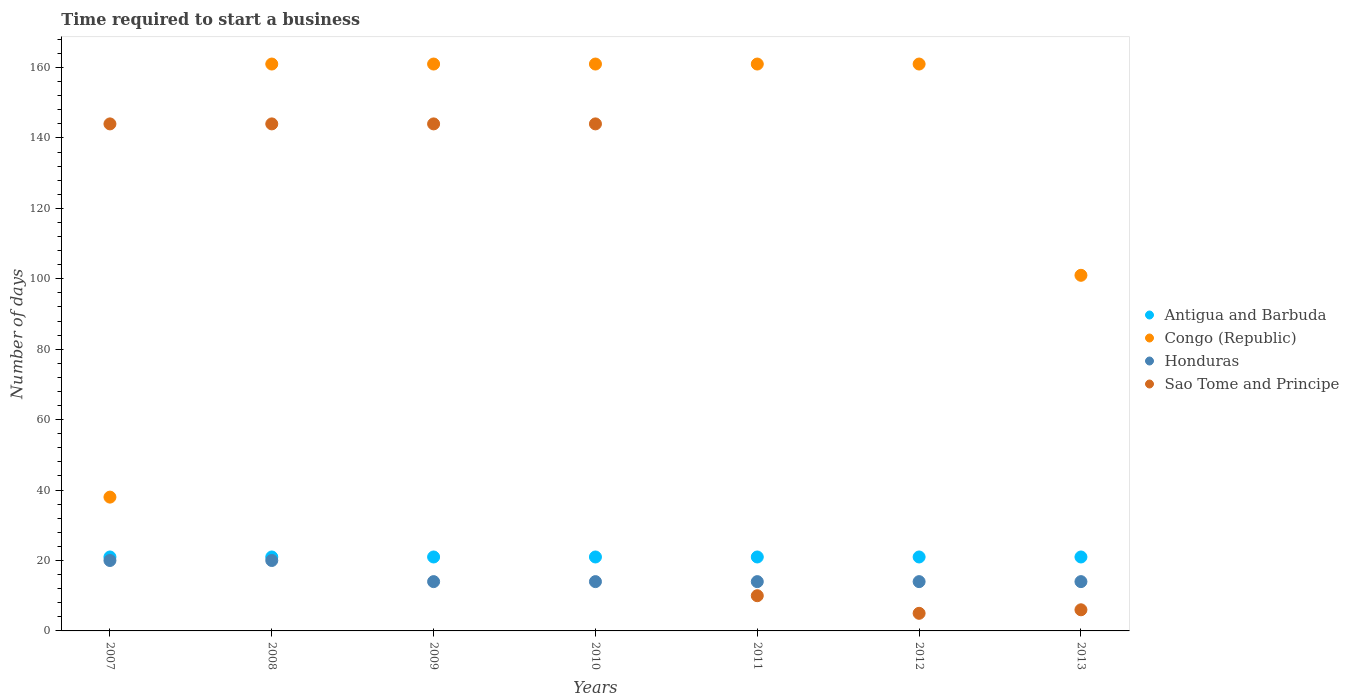How many different coloured dotlines are there?
Provide a short and direct response. 4. What is the number of days required to start a business in Sao Tome and Principe in 2007?
Your answer should be compact. 144. Across all years, what is the maximum number of days required to start a business in Sao Tome and Principe?
Ensure brevity in your answer.  144. Across all years, what is the minimum number of days required to start a business in Sao Tome and Principe?
Your response must be concise. 5. In which year was the number of days required to start a business in Antigua and Barbuda maximum?
Your response must be concise. 2007. In which year was the number of days required to start a business in Honduras minimum?
Offer a very short reply. 2009. What is the total number of days required to start a business in Honduras in the graph?
Provide a succinct answer. 110. What is the difference between the number of days required to start a business in Sao Tome and Principe in 2010 and that in 2013?
Ensure brevity in your answer.  138. What is the difference between the number of days required to start a business in Honduras in 2009 and the number of days required to start a business in Congo (Republic) in 2010?
Make the answer very short. -147. What is the average number of days required to start a business in Honduras per year?
Offer a very short reply. 15.71. In the year 2009, what is the difference between the number of days required to start a business in Antigua and Barbuda and number of days required to start a business in Congo (Republic)?
Your response must be concise. -140. What is the ratio of the number of days required to start a business in Sao Tome and Principe in 2012 to that in 2013?
Your answer should be very brief. 0.83. What is the difference between the highest and the second highest number of days required to start a business in Antigua and Barbuda?
Offer a very short reply. 0. What is the difference between the highest and the lowest number of days required to start a business in Congo (Republic)?
Provide a succinct answer. 123. In how many years, is the number of days required to start a business in Sao Tome and Principe greater than the average number of days required to start a business in Sao Tome and Principe taken over all years?
Make the answer very short. 4. Does the number of days required to start a business in Sao Tome and Principe monotonically increase over the years?
Keep it short and to the point. No. Is the number of days required to start a business in Honduras strictly greater than the number of days required to start a business in Sao Tome and Principe over the years?
Keep it short and to the point. No. Is the number of days required to start a business in Antigua and Barbuda strictly less than the number of days required to start a business in Sao Tome and Principe over the years?
Ensure brevity in your answer.  No. How many dotlines are there?
Provide a short and direct response. 4. How many years are there in the graph?
Your answer should be very brief. 7. Where does the legend appear in the graph?
Offer a very short reply. Center right. What is the title of the graph?
Offer a very short reply. Time required to start a business. What is the label or title of the X-axis?
Your answer should be very brief. Years. What is the label or title of the Y-axis?
Ensure brevity in your answer.  Number of days. What is the Number of days of Antigua and Barbuda in 2007?
Offer a very short reply. 21. What is the Number of days of Congo (Republic) in 2007?
Provide a succinct answer. 38. What is the Number of days of Sao Tome and Principe in 2007?
Your answer should be very brief. 144. What is the Number of days in Antigua and Barbuda in 2008?
Ensure brevity in your answer.  21. What is the Number of days of Congo (Republic) in 2008?
Keep it short and to the point. 161. What is the Number of days in Honduras in 2008?
Offer a very short reply. 20. What is the Number of days of Sao Tome and Principe in 2008?
Your answer should be very brief. 144. What is the Number of days in Congo (Republic) in 2009?
Give a very brief answer. 161. What is the Number of days of Honduras in 2009?
Ensure brevity in your answer.  14. What is the Number of days in Sao Tome and Principe in 2009?
Offer a very short reply. 144. What is the Number of days in Congo (Republic) in 2010?
Keep it short and to the point. 161. What is the Number of days of Sao Tome and Principe in 2010?
Offer a very short reply. 144. What is the Number of days of Antigua and Barbuda in 2011?
Offer a terse response. 21. What is the Number of days of Congo (Republic) in 2011?
Make the answer very short. 161. What is the Number of days of Honduras in 2011?
Your answer should be compact. 14. What is the Number of days of Antigua and Barbuda in 2012?
Ensure brevity in your answer.  21. What is the Number of days of Congo (Republic) in 2012?
Your response must be concise. 161. What is the Number of days in Honduras in 2012?
Your answer should be very brief. 14. What is the Number of days in Congo (Republic) in 2013?
Make the answer very short. 101. What is the Number of days of Honduras in 2013?
Provide a short and direct response. 14. Across all years, what is the maximum Number of days in Congo (Republic)?
Provide a succinct answer. 161. Across all years, what is the maximum Number of days in Sao Tome and Principe?
Provide a short and direct response. 144. Across all years, what is the minimum Number of days of Congo (Republic)?
Provide a succinct answer. 38. What is the total Number of days of Antigua and Barbuda in the graph?
Provide a succinct answer. 147. What is the total Number of days of Congo (Republic) in the graph?
Offer a terse response. 944. What is the total Number of days in Honduras in the graph?
Make the answer very short. 110. What is the total Number of days in Sao Tome and Principe in the graph?
Your response must be concise. 597. What is the difference between the Number of days of Congo (Republic) in 2007 and that in 2008?
Provide a short and direct response. -123. What is the difference between the Number of days in Honduras in 2007 and that in 2008?
Offer a very short reply. 0. What is the difference between the Number of days in Congo (Republic) in 2007 and that in 2009?
Provide a short and direct response. -123. What is the difference between the Number of days of Honduras in 2007 and that in 2009?
Your answer should be compact. 6. What is the difference between the Number of days in Sao Tome and Principe in 2007 and that in 2009?
Offer a very short reply. 0. What is the difference between the Number of days of Congo (Republic) in 2007 and that in 2010?
Ensure brevity in your answer.  -123. What is the difference between the Number of days of Sao Tome and Principe in 2007 and that in 2010?
Keep it short and to the point. 0. What is the difference between the Number of days in Antigua and Barbuda in 2007 and that in 2011?
Provide a succinct answer. 0. What is the difference between the Number of days of Congo (Republic) in 2007 and that in 2011?
Ensure brevity in your answer.  -123. What is the difference between the Number of days in Honduras in 2007 and that in 2011?
Provide a short and direct response. 6. What is the difference between the Number of days of Sao Tome and Principe in 2007 and that in 2011?
Offer a very short reply. 134. What is the difference between the Number of days in Antigua and Barbuda in 2007 and that in 2012?
Provide a succinct answer. 0. What is the difference between the Number of days of Congo (Republic) in 2007 and that in 2012?
Offer a very short reply. -123. What is the difference between the Number of days in Sao Tome and Principe in 2007 and that in 2012?
Your answer should be compact. 139. What is the difference between the Number of days in Antigua and Barbuda in 2007 and that in 2013?
Offer a terse response. 0. What is the difference between the Number of days of Congo (Republic) in 2007 and that in 2013?
Keep it short and to the point. -63. What is the difference between the Number of days of Honduras in 2007 and that in 2013?
Keep it short and to the point. 6. What is the difference between the Number of days of Sao Tome and Principe in 2007 and that in 2013?
Offer a very short reply. 138. What is the difference between the Number of days of Antigua and Barbuda in 2008 and that in 2009?
Make the answer very short. 0. What is the difference between the Number of days in Honduras in 2008 and that in 2009?
Make the answer very short. 6. What is the difference between the Number of days of Sao Tome and Principe in 2008 and that in 2009?
Offer a very short reply. 0. What is the difference between the Number of days of Antigua and Barbuda in 2008 and that in 2010?
Your answer should be compact. 0. What is the difference between the Number of days of Honduras in 2008 and that in 2010?
Offer a terse response. 6. What is the difference between the Number of days of Antigua and Barbuda in 2008 and that in 2011?
Your answer should be compact. 0. What is the difference between the Number of days in Congo (Republic) in 2008 and that in 2011?
Your response must be concise. 0. What is the difference between the Number of days of Sao Tome and Principe in 2008 and that in 2011?
Ensure brevity in your answer.  134. What is the difference between the Number of days in Antigua and Barbuda in 2008 and that in 2012?
Provide a succinct answer. 0. What is the difference between the Number of days of Congo (Republic) in 2008 and that in 2012?
Make the answer very short. 0. What is the difference between the Number of days of Honduras in 2008 and that in 2012?
Give a very brief answer. 6. What is the difference between the Number of days in Sao Tome and Principe in 2008 and that in 2012?
Offer a terse response. 139. What is the difference between the Number of days in Congo (Republic) in 2008 and that in 2013?
Keep it short and to the point. 60. What is the difference between the Number of days of Honduras in 2008 and that in 2013?
Your answer should be compact. 6. What is the difference between the Number of days in Sao Tome and Principe in 2008 and that in 2013?
Make the answer very short. 138. What is the difference between the Number of days in Sao Tome and Principe in 2009 and that in 2010?
Your response must be concise. 0. What is the difference between the Number of days in Congo (Republic) in 2009 and that in 2011?
Offer a very short reply. 0. What is the difference between the Number of days of Sao Tome and Principe in 2009 and that in 2011?
Make the answer very short. 134. What is the difference between the Number of days in Sao Tome and Principe in 2009 and that in 2012?
Provide a short and direct response. 139. What is the difference between the Number of days in Antigua and Barbuda in 2009 and that in 2013?
Offer a terse response. 0. What is the difference between the Number of days in Honduras in 2009 and that in 2013?
Your answer should be compact. 0. What is the difference between the Number of days of Sao Tome and Principe in 2009 and that in 2013?
Keep it short and to the point. 138. What is the difference between the Number of days of Congo (Republic) in 2010 and that in 2011?
Your answer should be very brief. 0. What is the difference between the Number of days of Sao Tome and Principe in 2010 and that in 2011?
Make the answer very short. 134. What is the difference between the Number of days of Congo (Republic) in 2010 and that in 2012?
Your answer should be very brief. 0. What is the difference between the Number of days in Honduras in 2010 and that in 2012?
Your answer should be compact. 0. What is the difference between the Number of days of Sao Tome and Principe in 2010 and that in 2012?
Your response must be concise. 139. What is the difference between the Number of days of Antigua and Barbuda in 2010 and that in 2013?
Your answer should be compact. 0. What is the difference between the Number of days in Honduras in 2010 and that in 2013?
Give a very brief answer. 0. What is the difference between the Number of days of Sao Tome and Principe in 2010 and that in 2013?
Your answer should be compact. 138. What is the difference between the Number of days of Congo (Republic) in 2011 and that in 2012?
Keep it short and to the point. 0. What is the difference between the Number of days of Antigua and Barbuda in 2011 and that in 2013?
Give a very brief answer. 0. What is the difference between the Number of days of Congo (Republic) in 2011 and that in 2013?
Make the answer very short. 60. What is the difference between the Number of days in Sao Tome and Principe in 2011 and that in 2013?
Make the answer very short. 4. What is the difference between the Number of days in Congo (Republic) in 2012 and that in 2013?
Your response must be concise. 60. What is the difference between the Number of days in Honduras in 2012 and that in 2013?
Make the answer very short. 0. What is the difference between the Number of days in Sao Tome and Principe in 2012 and that in 2013?
Ensure brevity in your answer.  -1. What is the difference between the Number of days of Antigua and Barbuda in 2007 and the Number of days of Congo (Republic) in 2008?
Provide a short and direct response. -140. What is the difference between the Number of days of Antigua and Barbuda in 2007 and the Number of days of Sao Tome and Principe in 2008?
Keep it short and to the point. -123. What is the difference between the Number of days of Congo (Republic) in 2007 and the Number of days of Sao Tome and Principe in 2008?
Offer a very short reply. -106. What is the difference between the Number of days in Honduras in 2007 and the Number of days in Sao Tome and Principe in 2008?
Ensure brevity in your answer.  -124. What is the difference between the Number of days in Antigua and Barbuda in 2007 and the Number of days in Congo (Republic) in 2009?
Provide a short and direct response. -140. What is the difference between the Number of days of Antigua and Barbuda in 2007 and the Number of days of Sao Tome and Principe in 2009?
Provide a succinct answer. -123. What is the difference between the Number of days in Congo (Republic) in 2007 and the Number of days in Honduras in 2009?
Keep it short and to the point. 24. What is the difference between the Number of days of Congo (Republic) in 2007 and the Number of days of Sao Tome and Principe in 2009?
Make the answer very short. -106. What is the difference between the Number of days in Honduras in 2007 and the Number of days in Sao Tome and Principe in 2009?
Your response must be concise. -124. What is the difference between the Number of days in Antigua and Barbuda in 2007 and the Number of days in Congo (Republic) in 2010?
Offer a terse response. -140. What is the difference between the Number of days of Antigua and Barbuda in 2007 and the Number of days of Sao Tome and Principe in 2010?
Ensure brevity in your answer.  -123. What is the difference between the Number of days of Congo (Republic) in 2007 and the Number of days of Honduras in 2010?
Your answer should be very brief. 24. What is the difference between the Number of days of Congo (Republic) in 2007 and the Number of days of Sao Tome and Principe in 2010?
Offer a very short reply. -106. What is the difference between the Number of days in Honduras in 2007 and the Number of days in Sao Tome and Principe in 2010?
Provide a succinct answer. -124. What is the difference between the Number of days of Antigua and Barbuda in 2007 and the Number of days of Congo (Republic) in 2011?
Offer a very short reply. -140. What is the difference between the Number of days of Antigua and Barbuda in 2007 and the Number of days of Honduras in 2011?
Keep it short and to the point. 7. What is the difference between the Number of days of Honduras in 2007 and the Number of days of Sao Tome and Principe in 2011?
Make the answer very short. 10. What is the difference between the Number of days in Antigua and Barbuda in 2007 and the Number of days in Congo (Republic) in 2012?
Your answer should be very brief. -140. What is the difference between the Number of days of Antigua and Barbuda in 2007 and the Number of days of Honduras in 2012?
Your answer should be very brief. 7. What is the difference between the Number of days of Antigua and Barbuda in 2007 and the Number of days of Sao Tome and Principe in 2012?
Ensure brevity in your answer.  16. What is the difference between the Number of days in Congo (Republic) in 2007 and the Number of days in Honduras in 2012?
Provide a succinct answer. 24. What is the difference between the Number of days of Honduras in 2007 and the Number of days of Sao Tome and Principe in 2012?
Offer a terse response. 15. What is the difference between the Number of days of Antigua and Barbuda in 2007 and the Number of days of Congo (Republic) in 2013?
Provide a short and direct response. -80. What is the difference between the Number of days in Antigua and Barbuda in 2007 and the Number of days in Honduras in 2013?
Keep it short and to the point. 7. What is the difference between the Number of days of Antigua and Barbuda in 2008 and the Number of days of Congo (Republic) in 2009?
Your answer should be very brief. -140. What is the difference between the Number of days in Antigua and Barbuda in 2008 and the Number of days in Honduras in 2009?
Provide a short and direct response. 7. What is the difference between the Number of days of Antigua and Barbuda in 2008 and the Number of days of Sao Tome and Principe in 2009?
Offer a very short reply. -123. What is the difference between the Number of days of Congo (Republic) in 2008 and the Number of days of Honduras in 2009?
Your answer should be very brief. 147. What is the difference between the Number of days in Congo (Republic) in 2008 and the Number of days in Sao Tome and Principe in 2009?
Offer a very short reply. 17. What is the difference between the Number of days of Honduras in 2008 and the Number of days of Sao Tome and Principe in 2009?
Give a very brief answer. -124. What is the difference between the Number of days of Antigua and Barbuda in 2008 and the Number of days of Congo (Republic) in 2010?
Your answer should be compact. -140. What is the difference between the Number of days in Antigua and Barbuda in 2008 and the Number of days in Honduras in 2010?
Make the answer very short. 7. What is the difference between the Number of days in Antigua and Barbuda in 2008 and the Number of days in Sao Tome and Principe in 2010?
Ensure brevity in your answer.  -123. What is the difference between the Number of days of Congo (Republic) in 2008 and the Number of days of Honduras in 2010?
Offer a terse response. 147. What is the difference between the Number of days in Congo (Republic) in 2008 and the Number of days in Sao Tome and Principe in 2010?
Offer a very short reply. 17. What is the difference between the Number of days of Honduras in 2008 and the Number of days of Sao Tome and Principe in 2010?
Offer a very short reply. -124. What is the difference between the Number of days of Antigua and Barbuda in 2008 and the Number of days of Congo (Republic) in 2011?
Your answer should be compact. -140. What is the difference between the Number of days of Antigua and Barbuda in 2008 and the Number of days of Sao Tome and Principe in 2011?
Make the answer very short. 11. What is the difference between the Number of days of Congo (Republic) in 2008 and the Number of days of Honduras in 2011?
Make the answer very short. 147. What is the difference between the Number of days in Congo (Republic) in 2008 and the Number of days in Sao Tome and Principe in 2011?
Your answer should be compact. 151. What is the difference between the Number of days in Honduras in 2008 and the Number of days in Sao Tome and Principe in 2011?
Provide a succinct answer. 10. What is the difference between the Number of days of Antigua and Barbuda in 2008 and the Number of days of Congo (Republic) in 2012?
Your response must be concise. -140. What is the difference between the Number of days in Antigua and Barbuda in 2008 and the Number of days in Honduras in 2012?
Keep it short and to the point. 7. What is the difference between the Number of days of Congo (Republic) in 2008 and the Number of days of Honduras in 2012?
Offer a terse response. 147. What is the difference between the Number of days of Congo (Republic) in 2008 and the Number of days of Sao Tome and Principe in 2012?
Give a very brief answer. 156. What is the difference between the Number of days in Honduras in 2008 and the Number of days in Sao Tome and Principe in 2012?
Provide a short and direct response. 15. What is the difference between the Number of days of Antigua and Barbuda in 2008 and the Number of days of Congo (Republic) in 2013?
Offer a terse response. -80. What is the difference between the Number of days in Antigua and Barbuda in 2008 and the Number of days in Honduras in 2013?
Your response must be concise. 7. What is the difference between the Number of days of Congo (Republic) in 2008 and the Number of days of Honduras in 2013?
Your answer should be compact. 147. What is the difference between the Number of days in Congo (Republic) in 2008 and the Number of days in Sao Tome and Principe in 2013?
Offer a very short reply. 155. What is the difference between the Number of days in Antigua and Barbuda in 2009 and the Number of days in Congo (Republic) in 2010?
Your answer should be very brief. -140. What is the difference between the Number of days in Antigua and Barbuda in 2009 and the Number of days in Honduras in 2010?
Make the answer very short. 7. What is the difference between the Number of days in Antigua and Barbuda in 2009 and the Number of days in Sao Tome and Principe in 2010?
Offer a very short reply. -123. What is the difference between the Number of days of Congo (Republic) in 2009 and the Number of days of Honduras in 2010?
Offer a very short reply. 147. What is the difference between the Number of days of Honduras in 2009 and the Number of days of Sao Tome and Principe in 2010?
Your answer should be very brief. -130. What is the difference between the Number of days in Antigua and Barbuda in 2009 and the Number of days in Congo (Republic) in 2011?
Provide a succinct answer. -140. What is the difference between the Number of days of Antigua and Barbuda in 2009 and the Number of days of Honduras in 2011?
Your response must be concise. 7. What is the difference between the Number of days in Congo (Republic) in 2009 and the Number of days in Honduras in 2011?
Your response must be concise. 147. What is the difference between the Number of days in Congo (Republic) in 2009 and the Number of days in Sao Tome and Principe in 2011?
Your answer should be compact. 151. What is the difference between the Number of days in Antigua and Barbuda in 2009 and the Number of days in Congo (Republic) in 2012?
Your answer should be very brief. -140. What is the difference between the Number of days of Antigua and Barbuda in 2009 and the Number of days of Honduras in 2012?
Your answer should be compact. 7. What is the difference between the Number of days of Antigua and Barbuda in 2009 and the Number of days of Sao Tome and Principe in 2012?
Your answer should be compact. 16. What is the difference between the Number of days of Congo (Republic) in 2009 and the Number of days of Honduras in 2012?
Provide a succinct answer. 147. What is the difference between the Number of days in Congo (Republic) in 2009 and the Number of days in Sao Tome and Principe in 2012?
Keep it short and to the point. 156. What is the difference between the Number of days of Honduras in 2009 and the Number of days of Sao Tome and Principe in 2012?
Make the answer very short. 9. What is the difference between the Number of days of Antigua and Barbuda in 2009 and the Number of days of Congo (Republic) in 2013?
Your response must be concise. -80. What is the difference between the Number of days in Antigua and Barbuda in 2009 and the Number of days in Honduras in 2013?
Ensure brevity in your answer.  7. What is the difference between the Number of days of Antigua and Barbuda in 2009 and the Number of days of Sao Tome and Principe in 2013?
Give a very brief answer. 15. What is the difference between the Number of days of Congo (Republic) in 2009 and the Number of days of Honduras in 2013?
Your answer should be compact. 147. What is the difference between the Number of days of Congo (Republic) in 2009 and the Number of days of Sao Tome and Principe in 2013?
Keep it short and to the point. 155. What is the difference between the Number of days of Antigua and Barbuda in 2010 and the Number of days of Congo (Republic) in 2011?
Your answer should be very brief. -140. What is the difference between the Number of days in Antigua and Barbuda in 2010 and the Number of days in Sao Tome and Principe in 2011?
Provide a short and direct response. 11. What is the difference between the Number of days of Congo (Republic) in 2010 and the Number of days of Honduras in 2011?
Provide a succinct answer. 147. What is the difference between the Number of days of Congo (Republic) in 2010 and the Number of days of Sao Tome and Principe in 2011?
Provide a succinct answer. 151. What is the difference between the Number of days of Antigua and Barbuda in 2010 and the Number of days of Congo (Republic) in 2012?
Provide a succinct answer. -140. What is the difference between the Number of days in Antigua and Barbuda in 2010 and the Number of days in Honduras in 2012?
Your response must be concise. 7. What is the difference between the Number of days in Antigua and Barbuda in 2010 and the Number of days in Sao Tome and Principe in 2012?
Make the answer very short. 16. What is the difference between the Number of days in Congo (Republic) in 2010 and the Number of days in Honduras in 2012?
Keep it short and to the point. 147. What is the difference between the Number of days in Congo (Republic) in 2010 and the Number of days in Sao Tome and Principe in 2012?
Your answer should be very brief. 156. What is the difference between the Number of days in Antigua and Barbuda in 2010 and the Number of days in Congo (Republic) in 2013?
Ensure brevity in your answer.  -80. What is the difference between the Number of days in Antigua and Barbuda in 2010 and the Number of days in Honduras in 2013?
Your answer should be compact. 7. What is the difference between the Number of days in Antigua and Barbuda in 2010 and the Number of days in Sao Tome and Principe in 2013?
Give a very brief answer. 15. What is the difference between the Number of days of Congo (Republic) in 2010 and the Number of days of Honduras in 2013?
Keep it short and to the point. 147. What is the difference between the Number of days of Congo (Republic) in 2010 and the Number of days of Sao Tome and Principe in 2013?
Offer a very short reply. 155. What is the difference between the Number of days of Antigua and Barbuda in 2011 and the Number of days of Congo (Republic) in 2012?
Provide a short and direct response. -140. What is the difference between the Number of days in Antigua and Barbuda in 2011 and the Number of days in Honduras in 2012?
Give a very brief answer. 7. What is the difference between the Number of days of Antigua and Barbuda in 2011 and the Number of days of Sao Tome and Principe in 2012?
Give a very brief answer. 16. What is the difference between the Number of days in Congo (Republic) in 2011 and the Number of days in Honduras in 2012?
Provide a succinct answer. 147. What is the difference between the Number of days in Congo (Republic) in 2011 and the Number of days in Sao Tome and Principe in 2012?
Offer a terse response. 156. What is the difference between the Number of days of Honduras in 2011 and the Number of days of Sao Tome and Principe in 2012?
Your answer should be very brief. 9. What is the difference between the Number of days in Antigua and Barbuda in 2011 and the Number of days in Congo (Republic) in 2013?
Your answer should be compact. -80. What is the difference between the Number of days of Antigua and Barbuda in 2011 and the Number of days of Honduras in 2013?
Offer a terse response. 7. What is the difference between the Number of days of Antigua and Barbuda in 2011 and the Number of days of Sao Tome and Principe in 2013?
Make the answer very short. 15. What is the difference between the Number of days in Congo (Republic) in 2011 and the Number of days in Honduras in 2013?
Make the answer very short. 147. What is the difference between the Number of days in Congo (Republic) in 2011 and the Number of days in Sao Tome and Principe in 2013?
Your response must be concise. 155. What is the difference between the Number of days in Honduras in 2011 and the Number of days in Sao Tome and Principe in 2013?
Your response must be concise. 8. What is the difference between the Number of days in Antigua and Barbuda in 2012 and the Number of days in Congo (Republic) in 2013?
Keep it short and to the point. -80. What is the difference between the Number of days of Congo (Republic) in 2012 and the Number of days of Honduras in 2013?
Provide a succinct answer. 147. What is the difference between the Number of days of Congo (Republic) in 2012 and the Number of days of Sao Tome and Principe in 2013?
Your answer should be very brief. 155. What is the average Number of days in Congo (Republic) per year?
Ensure brevity in your answer.  134.86. What is the average Number of days of Honduras per year?
Keep it short and to the point. 15.71. What is the average Number of days of Sao Tome and Principe per year?
Your answer should be very brief. 85.29. In the year 2007, what is the difference between the Number of days of Antigua and Barbuda and Number of days of Congo (Republic)?
Provide a short and direct response. -17. In the year 2007, what is the difference between the Number of days in Antigua and Barbuda and Number of days in Honduras?
Offer a terse response. 1. In the year 2007, what is the difference between the Number of days of Antigua and Barbuda and Number of days of Sao Tome and Principe?
Offer a terse response. -123. In the year 2007, what is the difference between the Number of days in Congo (Republic) and Number of days in Honduras?
Provide a succinct answer. 18. In the year 2007, what is the difference between the Number of days in Congo (Republic) and Number of days in Sao Tome and Principe?
Your answer should be very brief. -106. In the year 2007, what is the difference between the Number of days of Honduras and Number of days of Sao Tome and Principe?
Ensure brevity in your answer.  -124. In the year 2008, what is the difference between the Number of days of Antigua and Barbuda and Number of days of Congo (Republic)?
Make the answer very short. -140. In the year 2008, what is the difference between the Number of days in Antigua and Barbuda and Number of days in Honduras?
Provide a short and direct response. 1. In the year 2008, what is the difference between the Number of days of Antigua and Barbuda and Number of days of Sao Tome and Principe?
Your response must be concise. -123. In the year 2008, what is the difference between the Number of days of Congo (Republic) and Number of days of Honduras?
Your response must be concise. 141. In the year 2008, what is the difference between the Number of days of Honduras and Number of days of Sao Tome and Principe?
Offer a terse response. -124. In the year 2009, what is the difference between the Number of days of Antigua and Barbuda and Number of days of Congo (Republic)?
Make the answer very short. -140. In the year 2009, what is the difference between the Number of days of Antigua and Barbuda and Number of days of Sao Tome and Principe?
Ensure brevity in your answer.  -123. In the year 2009, what is the difference between the Number of days in Congo (Republic) and Number of days in Honduras?
Provide a short and direct response. 147. In the year 2009, what is the difference between the Number of days of Honduras and Number of days of Sao Tome and Principe?
Your response must be concise. -130. In the year 2010, what is the difference between the Number of days of Antigua and Barbuda and Number of days of Congo (Republic)?
Provide a short and direct response. -140. In the year 2010, what is the difference between the Number of days in Antigua and Barbuda and Number of days in Honduras?
Make the answer very short. 7. In the year 2010, what is the difference between the Number of days in Antigua and Barbuda and Number of days in Sao Tome and Principe?
Provide a succinct answer. -123. In the year 2010, what is the difference between the Number of days in Congo (Republic) and Number of days in Honduras?
Offer a very short reply. 147. In the year 2010, what is the difference between the Number of days in Congo (Republic) and Number of days in Sao Tome and Principe?
Give a very brief answer. 17. In the year 2010, what is the difference between the Number of days in Honduras and Number of days in Sao Tome and Principe?
Provide a succinct answer. -130. In the year 2011, what is the difference between the Number of days of Antigua and Barbuda and Number of days of Congo (Republic)?
Ensure brevity in your answer.  -140. In the year 2011, what is the difference between the Number of days of Antigua and Barbuda and Number of days of Sao Tome and Principe?
Make the answer very short. 11. In the year 2011, what is the difference between the Number of days of Congo (Republic) and Number of days of Honduras?
Your answer should be compact. 147. In the year 2011, what is the difference between the Number of days in Congo (Republic) and Number of days in Sao Tome and Principe?
Provide a short and direct response. 151. In the year 2012, what is the difference between the Number of days in Antigua and Barbuda and Number of days in Congo (Republic)?
Make the answer very short. -140. In the year 2012, what is the difference between the Number of days of Congo (Republic) and Number of days of Honduras?
Provide a short and direct response. 147. In the year 2012, what is the difference between the Number of days in Congo (Republic) and Number of days in Sao Tome and Principe?
Your answer should be very brief. 156. In the year 2013, what is the difference between the Number of days of Antigua and Barbuda and Number of days of Congo (Republic)?
Your answer should be compact. -80. In the year 2013, what is the difference between the Number of days in Antigua and Barbuda and Number of days in Sao Tome and Principe?
Give a very brief answer. 15. In the year 2013, what is the difference between the Number of days in Congo (Republic) and Number of days in Honduras?
Your response must be concise. 87. What is the ratio of the Number of days in Antigua and Barbuda in 2007 to that in 2008?
Your answer should be compact. 1. What is the ratio of the Number of days in Congo (Republic) in 2007 to that in 2008?
Offer a very short reply. 0.24. What is the ratio of the Number of days in Sao Tome and Principe in 2007 to that in 2008?
Provide a short and direct response. 1. What is the ratio of the Number of days in Congo (Republic) in 2007 to that in 2009?
Your response must be concise. 0.24. What is the ratio of the Number of days in Honduras in 2007 to that in 2009?
Make the answer very short. 1.43. What is the ratio of the Number of days in Sao Tome and Principe in 2007 to that in 2009?
Ensure brevity in your answer.  1. What is the ratio of the Number of days of Congo (Republic) in 2007 to that in 2010?
Make the answer very short. 0.24. What is the ratio of the Number of days in Honduras in 2007 to that in 2010?
Offer a very short reply. 1.43. What is the ratio of the Number of days of Sao Tome and Principe in 2007 to that in 2010?
Offer a very short reply. 1. What is the ratio of the Number of days of Antigua and Barbuda in 2007 to that in 2011?
Offer a very short reply. 1. What is the ratio of the Number of days of Congo (Republic) in 2007 to that in 2011?
Ensure brevity in your answer.  0.24. What is the ratio of the Number of days of Honduras in 2007 to that in 2011?
Make the answer very short. 1.43. What is the ratio of the Number of days of Sao Tome and Principe in 2007 to that in 2011?
Keep it short and to the point. 14.4. What is the ratio of the Number of days of Antigua and Barbuda in 2007 to that in 2012?
Give a very brief answer. 1. What is the ratio of the Number of days of Congo (Republic) in 2007 to that in 2012?
Make the answer very short. 0.24. What is the ratio of the Number of days of Honduras in 2007 to that in 2012?
Offer a very short reply. 1.43. What is the ratio of the Number of days in Sao Tome and Principe in 2007 to that in 2012?
Provide a short and direct response. 28.8. What is the ratio of the Number of days of Antigua and Barbuda in 2007 to that in 2013?
Provide a succinct answer. 1. What is the ratio of the Number of days in Congo (Republic) in 2007 to that in 2013?
Your answer should be very brief. 0.38. What is the ratio of the Number of days in Honduras in 2007 to that in 2013?
Make the answer very short. 1.43. What is the ratio of the Number of days in Sao Tome and Principe in 2007 to that in 2013?
Your answer should be compact. 24. What is the ratio of the Number of days in Antigua and Barbuda in 2008 to that in 2009?
Keep it short and to the point. 1. What is the ratio of the Number of days in Honduras in 2008 to that in 2009?
Your response must be concise. 1.43. What is the ratio of the Number of days of Sao Tome and Principe in 2008 to that in 2009?
Keep it short and to the point. 1. What is the ratio of the Number of days of Antigua and Barbuda in 2008 to that in 2010?
Give a very brief answer. 1. What is the ratio of the Number of days in Honduras in 2008 to that in 2010?
Ensure brevity in your answer.  1.43. What is the ratio of the Number of days of Antigua and Barbuda in 2008 to that in 2011?
Keep it short and to the point. 1. What is the ratio of the Number of days in Honduras in 2008 to that in 2011?
Offer a terse response. 1.43. What is the ratio of the Number of days of Sao Tome and Principe in 2008 to that in 2011?
Your response must be concise. 14.4. What is the ratio of the Number of days in Congo (Republic) in 2008 to that in 2012?
Your response must be concise. 1. What is the ratio of the Number of days of Honduras in 2008 to that in 2012?
Ensure brevity in your answer.  1.43. What is the ratio of the Number of days of Sao Tome and Principe in 2008 to that in 2012?
Your response must be concise. 28.8. What is the ratio of the Number of days in Antigua and Barbuda in 2008 to that in 2013?
Offer a very short reply. 1. What is the ratio of the Number of days in Congo (Republic) in 2008 to that in 2013?
Offer a terse response. 1.59. What is the ratio of the Number of days of Honduras in 2008 to that in 2013?
Offer a very short reply. 1.43. What is the ratio of the Number of days of Congo (Republic) in 2009 to that in 2010?
Offer a very short reply. 1. What is the ratio of the Number of days in Sao Tome and Principe in 2009 to that in 2010?
Your response must be concise. 1. What is the ratio of the Number of days in Sao Tome and Principe in 2009 to that in 2011?
Give a very brief answer. 14.4. What is the ratio of the Number of days in Antigua and Barbuda in 2009 to that in 2012?
Provide a short and direct response. 1. What is the ratio of the Number of days of Congo (Republic) in 2009 to that in 2012?
Your answer should be compact. 1. What is the ratio of the Number of days in Sao Tome and Principe in 2009 to that in 2012?
Provide a succinct answer. 28.8. What is the ratio of the Number of days in Congo (Republic) in 2009 to that in 2013?
Your answer should be compact. 1.59. What is the ratio of the Number of days of Honduras in 2009 to that in 2013?
Offer a terse response. 1. What is the ratio of the Number of days of Antigua and Barbuda in 2010 to that in 2011?
Provide a short and direct response. 1. What is the ratio of the Number of days of Honduras in 2010 to that in 2011?
Ensure brevity in your answer.  1. What is the ratio of the Number of days in Sao Tome and Principe in 2010 to that in 2011?
Your answer should be very brief. 14.4. What is the ratio of the Number of days of Congo (Republic) in 2010 to that in 2012?
Give a very brief answer. 1. What is the ratio of the Number of days of Honduras in 2010 to that in 2012?
Provide a short and direct response. 1. What is the ratio of the Number of days of Sao Tome and Principe in 2010 to that in 2012?
Provide a short and direct response. 28.8. What is the ratio of the Number of days of Antigua and Barbuda in 2010 to that in 2013?
Provide a succinct answer. 1. What is the ratio of the Number of days of Congo (Republic) in 2010 to that in 2013?
Your answer should be very brief. 1.59. What is the ratio of the Number of days in Antigua and Barbuda in 2011 to that in 2012?
Offer a terse response. 1. What is the ratio of the Number of days in Congo (Republic) in 2011 to that in 2012?
Keep it short and to the point. 1. What is the ratio of the Number of days of Honduras in 2011 to that in 2012?
Your response must be concise. 1. What is the ratio of the Number of days of Sao Tome and Principe in 2011 to that in 2012?
Offer a terse response. 2. What is the ratio of the Number of days in Congo (Republic) in 2011 to that in 2013?
Offer a terse response. 1.59. What is the ratio of the Number of days in Congo (Republic) in 2012 to that in 2013?
Offer a very short reply. 1.59. What is the difference between the highest and the second highest Number of days of Antigua and Barbuda?
Offer a terse response. 0. What is the difference between the highest and the lowest Number of days of Congo (Republic)?
Offer a terse response. 123. What is the difference between the highest and the lowest Number of days in Sao Tome and Principe?
Provide a short and direct response. 139. 